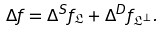Convert formula to latex. <formula><loc_0><loc_0><loc_500><loc_500>\Delta f = \Delta ^ { S } f _ { \mathfrak { L } } + \Delta ^ { D } f _ { \mathfrak { L } ^ { \perp } } .</formula> 